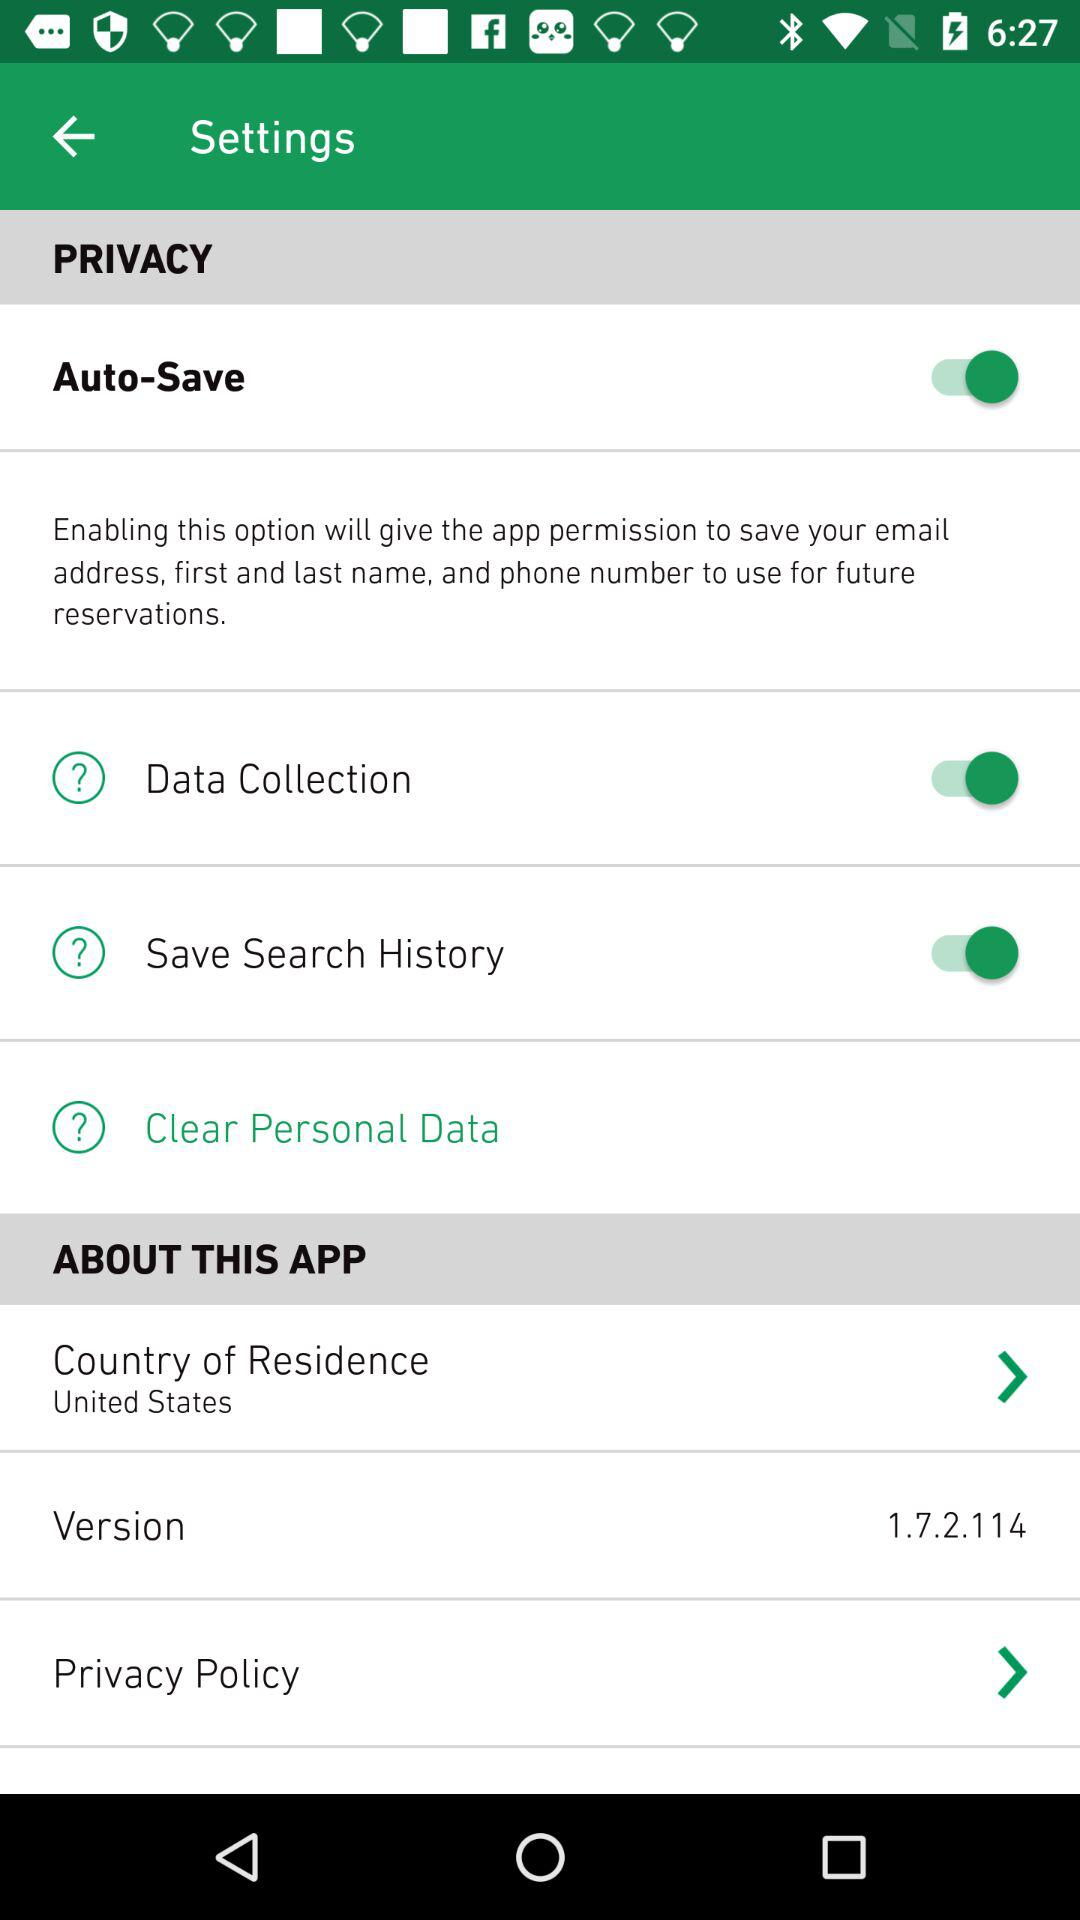What is the country of residence? The country of residence is the United States. 